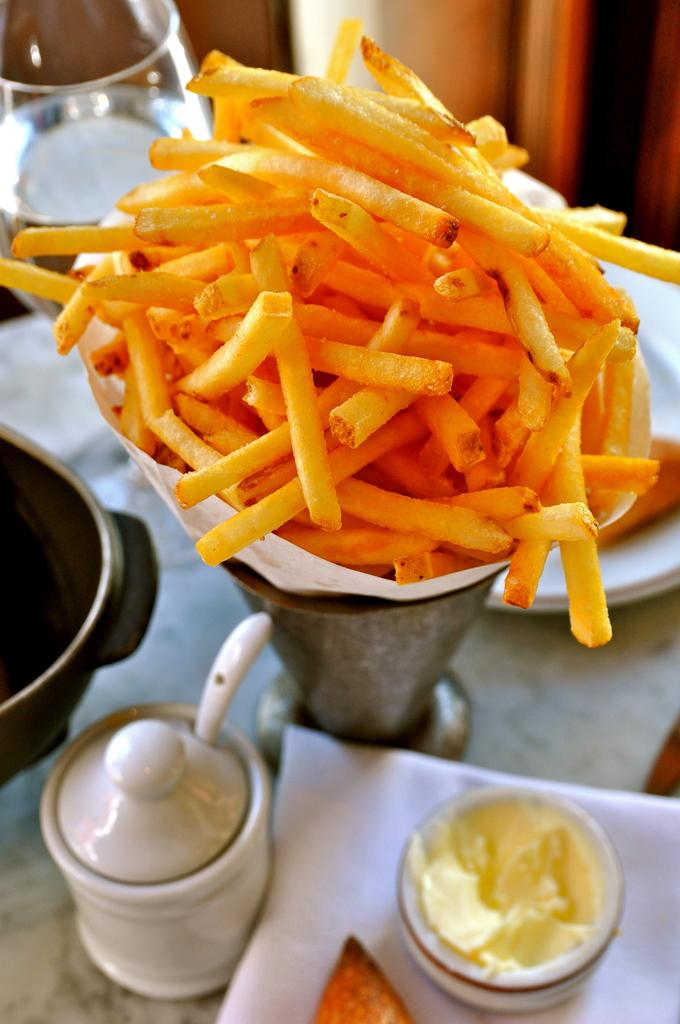What types of items can be seen in the image? There are food items in the image. What is the primary location of these items? The food items are on a table. Are there any other objects present in the image? Yes, there are objects on the table and near the table. What type of tub is visible in the image? There is no tub present in the image. 